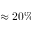Convert formula to latex. <formula><loc_0><loc_0><loc_500><loc_500>\approx 2 0 \%</formula> 